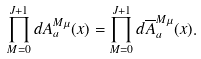Convert formula to latex. <formula><loc_0><loc_0><loc_500><loc_500>\prod _ { M = 0 } ^ { J + 1 } d A ^ { M \mu } _ { a } ( { x } ) = \prod _ { M = 0 } ^ { J + 1 } d \overline { A } ^ { M \mu } _ { a } ( { x } ) .</formula> 